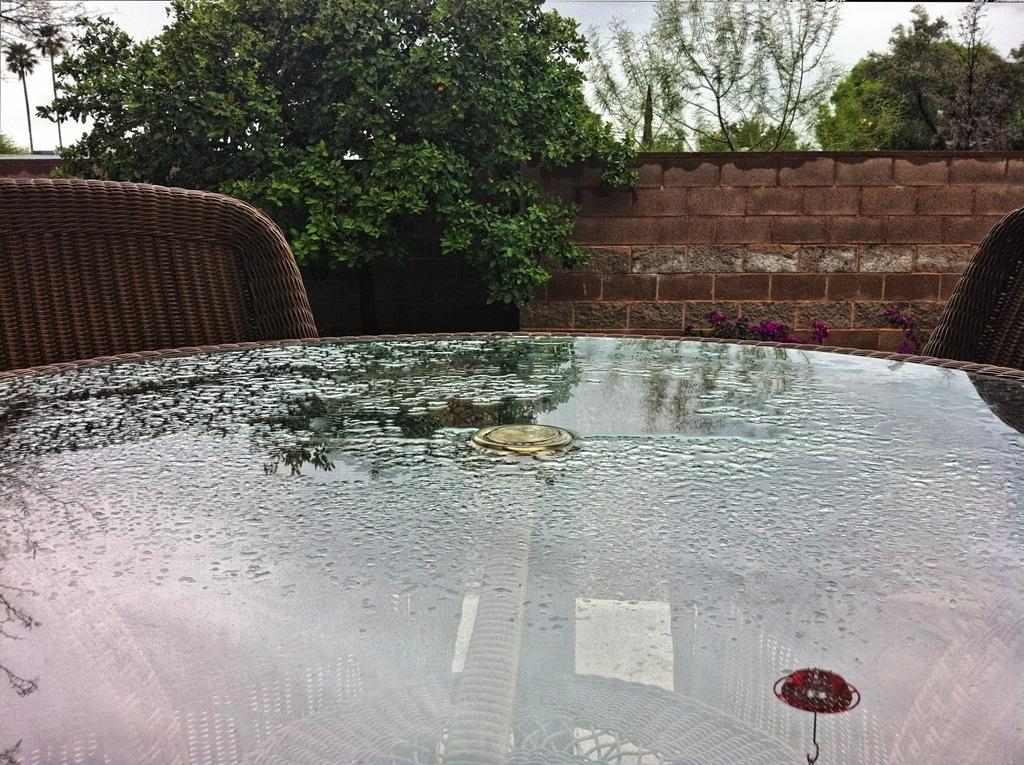What type of table is visible in the image? There is a glass table in the image. What furniture can be seen in the background of the image? There are two chairs in the background of the image. What type of vegetation is present in the image? There are trees with green color in the image. What is the color of the wall in the image? The wall has a brown color. What is the color of the sky in the image? The sky appears to be white in color. What type of texture can be seen on the liquid in the image? There is no liquid present in the image; it features a glass table, chairs, trees, a brown wall, and a white sky. What type of clouds are visible in the image? There are no clouds visible in the image; the sky appears to be white in color. 